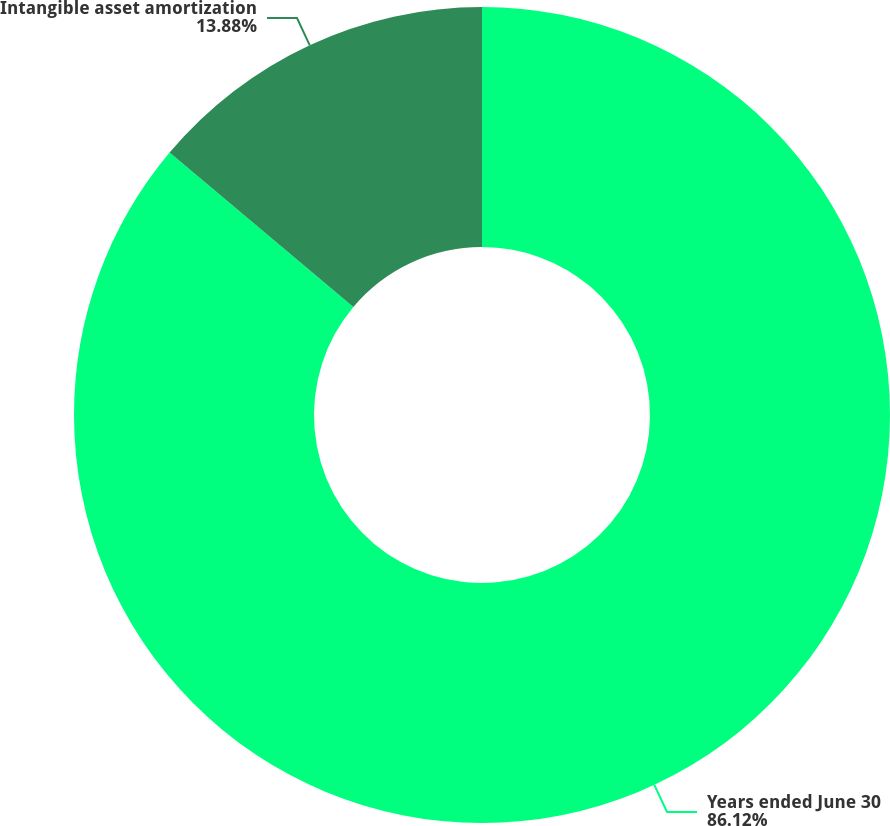Convert chart to OTSL. <chart><loc_0><loc_0><loc_500><loc_500><pie_chart><fcel>Years ended June 30<fcel>Intangible asset amortization<nl><fcel>86.12%<fcel>13.88%<nl></chart> 